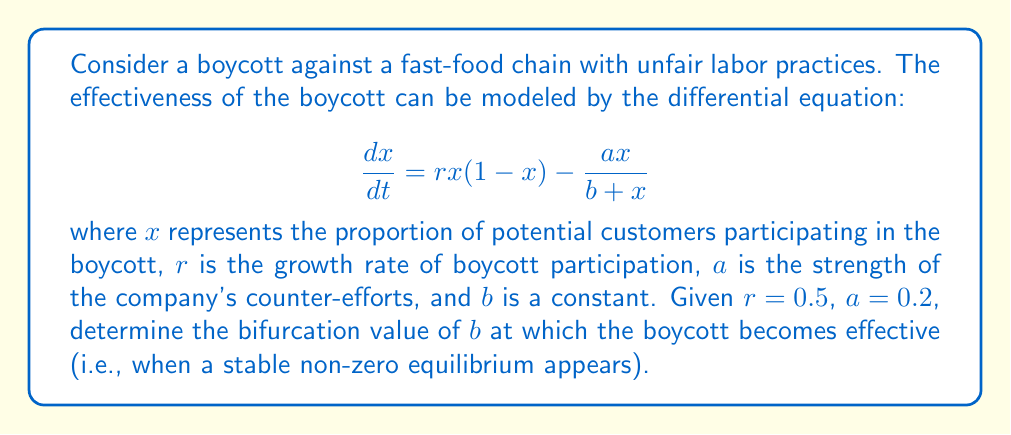Show me your answer to this math problem. To solve this problem, we'll follow these steps:

1) First, we need to find the equilibrium points by setting $\frac{dx}{dt} = 0$:

   $$0 = rx(1-x) - \frac{ax}{b+x}$$

2) Rearranging the equation:

   $$rx(1-x)(b+x) = ax$$

3) Expanding:

   $$rx(b+x-bx-x^2) = ax$$
   $$rxb + rx^2 - rbx^2 - rx^3 = ax$$

4) Collecting terms:

   $$-rx^3 - (rb-r)x^2 + (rb-a)x = 0$$

5) Factoring out $x$:

   $$x[-rx^2 - (rb-r)x + (rb-a)] = 0$$

6) The solutions to this equation are $x=0$ and the roots of the quadratic equation:

   $$-rx^2 - (rb-r)x + (rb-a) = 0$$

7) For a bifurcation to occur, this quadratic should have a double root, which happens when its discriminant is zero. The discriminant is given by $B^2 - 4AC$ for a quadratic $Ax^2 + Bx + C = 0$. So:

   $$(rb-r)^2 - 4(-r)(rb-a) = 0$$

8) Expanding:

   $$r^2b^2 - 2r^2b + r^2 + 4r^2b - 4ra = 0$$

9) Simplifying:

   $$r^2b^2 + 2r^2b + r^2 - 4ra = 0$$

10) Substituting the given values $r=0.5$ and $a=0.2$:

    $$0.25b^2 + 0.5b + 0.25 - 0.4 = 0$$
    $$0.25b^2 + 0.5b - 0.15 = 0$$

11) Solving this quadratic equation:

    $$b = \frac{-0.5 \pm \sqrt{0.25 + 0.15}}{0.5} = -1 \pm \sqrt{1.6}$$

12) Since $b$ must be positive, we take the positive root:

    $$b = -1 + \sqrt{1.6} \approx 0.2649$$

This value of $b$ is the bifurcation point at which the boycott becomes effective.
Answer: $b \approx 0.2649$ 